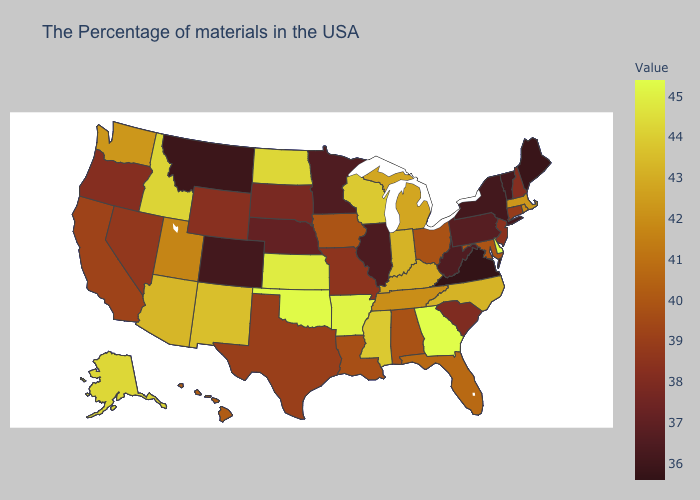Among the states that border New Hampshire , does Vermont have the lowest value?
Keep it brief. No. Does Maine have the lowest value in the Northeast?
Write a very short answer. Yes. Is the legend a continuous bar?
Keep it brief. Yes. Does Kansas have the highest value in the MidWest?
Concise answer only. Yes. Among the states that border North Dakota , which have the lowest value?
Concise answer only. Montana. 